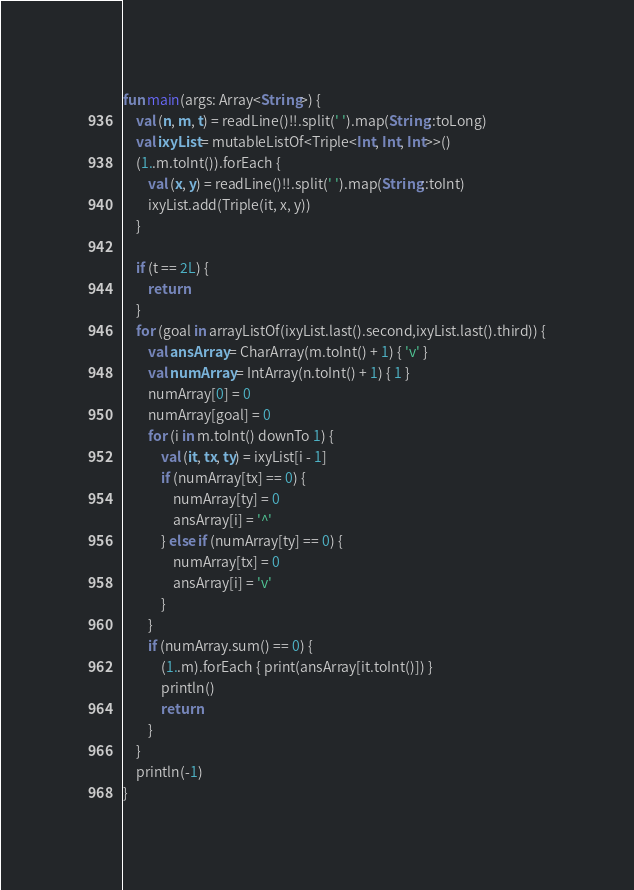<code> <loc_0><loc_0><loc_500><loc_500><_Kotlin_>fun main(args: Array<String>) {
    val (n, m, t) = readLine()!!.split(' ').map(String::toLong)
    val ixyList = mutableListOf<Triple<Int, Int, Int>>()
    (1..m.toInt()).forEach {
        val (x, y) = readLine()!!.split(' ').map(String::toInt)
        ixyList.add(Triple(it, x, y))
    }

    if (t == 2L) {
        return
    }
    for (goal in arrayListOf(ixyList.last().second,ixyList.last().third)) {
        val ansArray = CharArray(m.toInt() + 1) { 'v' }
        val numArray = IntArray(n.toInt() + 1) { 1 }
        numArray[0] = 0
        numArray[goal] = 0
        for (i in m.toInt() downTo 1) {
            val (it, tx, ty) = ixyList[i - 1]
            if (numArray[tx] == 0) {
                numArray[ty] = 0
                ansArray[i] = '^'
            } else if (numArray[ty] == 0) {
                numArray[tx] = 0
                ansArray[i] = 'v'
            }
        }
        if (numArray.sum() == 0) {
            (1..m).forEach { print(ansArray[it.toInt()]) }
            println()
            return
        }
    }
    println(-1)
}</code> 